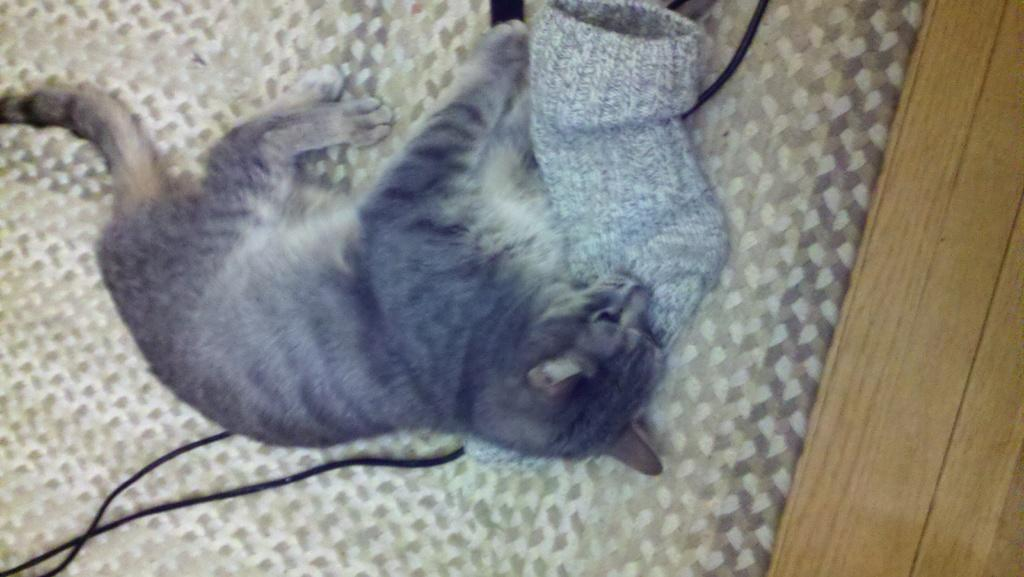What animal can be seen in the image? There is a cat on a cloth in the image. What type of object is present in the image that is typically used for transmitting electricity? There is a wire in the image. What type of clothing item can be seen in the image? There are socks in the image. What type of material is present in the image that is commonly used for making furniture or other objects? There is a wooden stick in the image. What type of trail can be seen in the image? There is no trail present in the image. Can you tell me what type of joke the cat is telling in the image? There is no joke being told in the image; it is a static image of a cat on a cloth. 